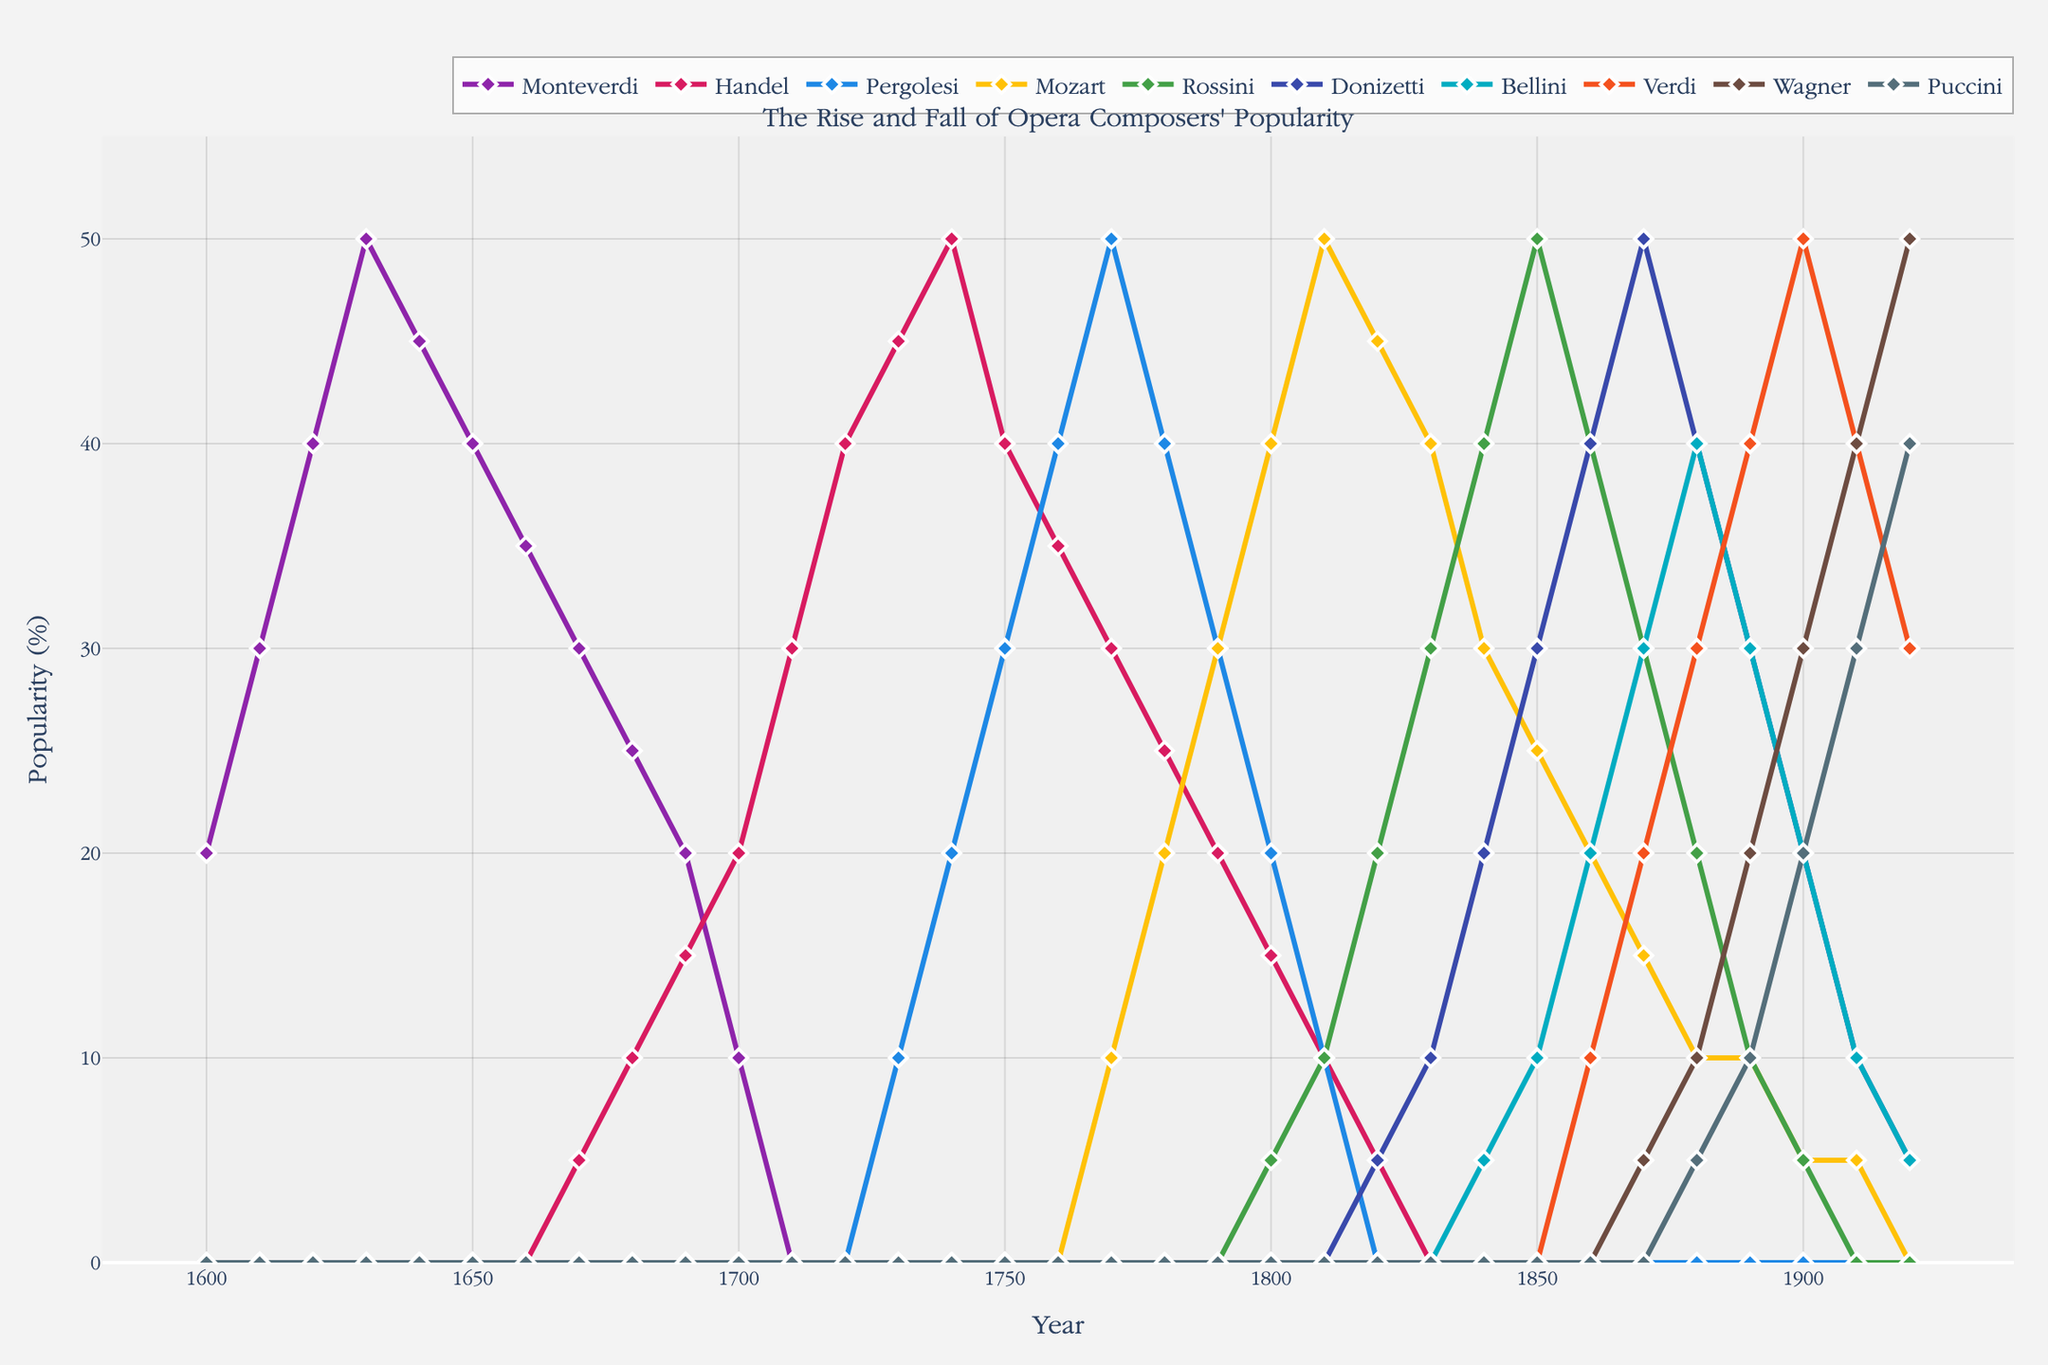What is the title of the plot? The title is located at the top of the plot and provides a summary of what the plot is about. Here, the title indicates the purpose of the time series plot.
Answer: The Rise and Fall of Opera Composers' Popularity Which composer shows a sharp decline in popularity around the year 1700? By examining the plot around the year 1700, we can observe which composer's line drops sharply. In this period, the composer's popularity that decreases notably is Handel's.
Answer: Handel Who was the most popular composer in 1800? To find the most popular composer in 1800, we look at the data points corresponding to the year 1800 and identify the highest value. Mozart's line is at its peak during this year.
Answer: Mozart Compare the popularity of Wagner and Puccini in the year 1910. Who was more popular? Referring to the year 1910 on the x-axis, we compare the y-values for Wagner and Puccini. Wagner's value is higher than Puccini’s at this point.
Answer: Wagner What was Verdi's popularity trend from 1850 to 1900? To understand Verdi's trend, follow his line on the plot from 1850 to 1900. Verdi's popularity line increases steadily, peaking around 1900.
Answer: Increasing steadily Between which years did Rossini's popularity peak and then decline? Rossini's popularity peaks and declines within specific years. By following Rossini's line, we observe a peak around 1850 and a decline afterward.
Answer: 1850 and 1860 How does the popularity of Monteverdi change from 1600 to 1650? We trace Monteverdi's line from 1600 to 1650 to observe the changes in popularity, noting an initial rise followed by a subsequent fall.
Answer: Initial rise, then fall Who showed a continual rise in popularity from the early 20th century to 1920? By looking at the composer's lines from around the early 20th century to 1920, Puccini's line shows a continual rise during this period.
Answer: Puccini At which decade did Donizetti reach his peak popularity, and what was the value? We identify the highest point on Donizetti's line and note the corresponding decade and value. Donizetti peaks in the 1870s.
Answer: 1870s, 50% In which year did Pergolesi's popularity fall to zero? Checking the plot for Pergolesi, we look for the year when his line touches zero. This occurs in 1820.
Answer: 1820 